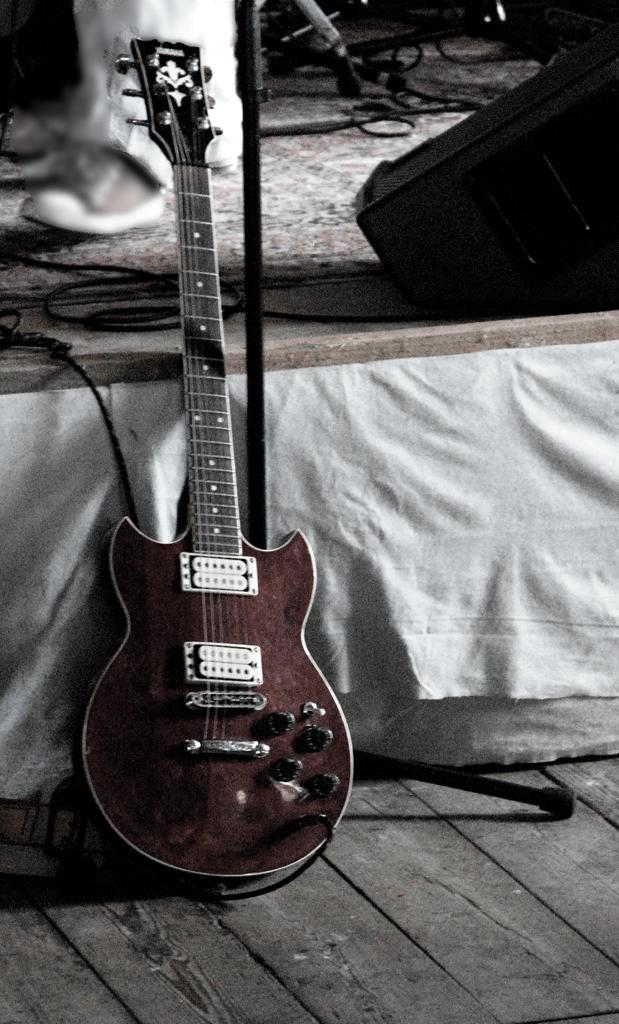What musical instrument is in the image? There is a guitar in the image. What is behind the guitar? There are wires behind the guitar. Whose legs are visible in the image? The legs of a person are visible in the image. What type of footwear is present in the image? A shoe is present in the image. What type of corn is being used as a pick for the guitar in the image? There is no corn present in the image, and the guitar is not being played in the image. 